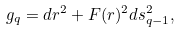<formula> <loc_0><loc_0><loc_500><loc_500>g _ { q } = d r ^ { 2 } + F ( r ) ^ { 2 } d s _ { q - 1 } ^ { 2 } ,</formula> 